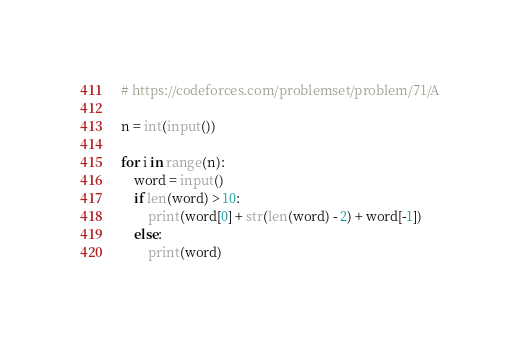<code> <loc_0><loc_0><loc_500><loc_500><_Python_># https://codeforces.com/problemset/problem/71/A

n = int(input())

for i in range(n):
    word = input()
    if len(word) > 10:
        print(word[0] + str(len(word) - 2) + word[-1])
    else:
        print(word)
</code> 